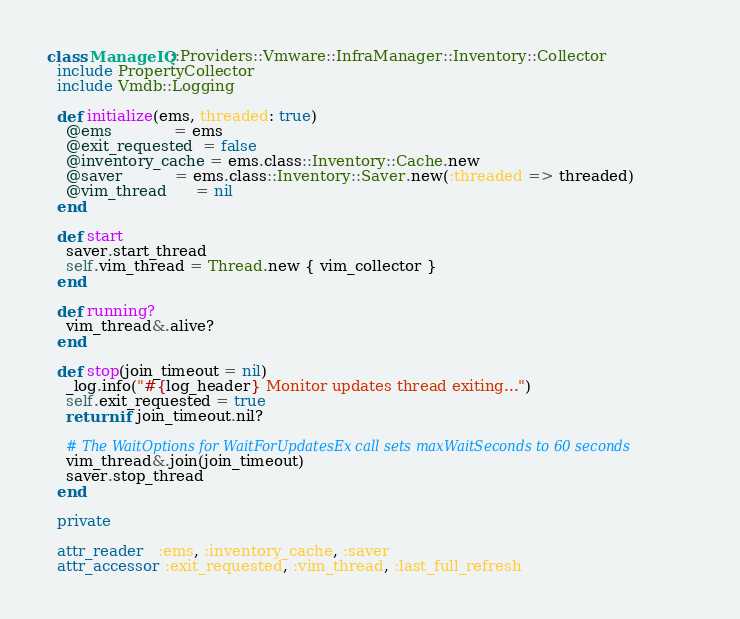<code> <loc_0><loc_0><loc_500><loc_500><_Ruby_>class ManageIQ::Providers::Vmware::InfraManager::Inventory::Collector
  include PropertyCollector
  include Vmdb::Logging

  def initialize(ems, threaded: true)
    @ems             = ems
    @exit_requested  = false
    @inventory_cache = ems.class::Inventory::Cache.new
    @saver           = ems.class::Inventory::Saver.new(:threaded => threaded)
    @vim_thread      = nil
  end

  def start
    saver.start_thread
    self.vim_thread = Thread.new { vim_collector }
  end

  def running?
    vim_thread&.alive?
  end

  def stop(join_timeout = nil)
    _log.info("#{log_header} Monitor updates thread exiting...")
    self.exit_requested = true
    return if join_timeout.nil?

    # The WaitOptions for WaitForUpdatesEx call sets maxWaitSeconds to 60 seconds
    vim_thread&.join(join_timeout)
    saver.stop_thread
  end

  private

  attr_reader   :ems, :inventory_cache, :saver
  attr_accessor :exit_requested, :vim_thread, :last_full_refresh
</code> 